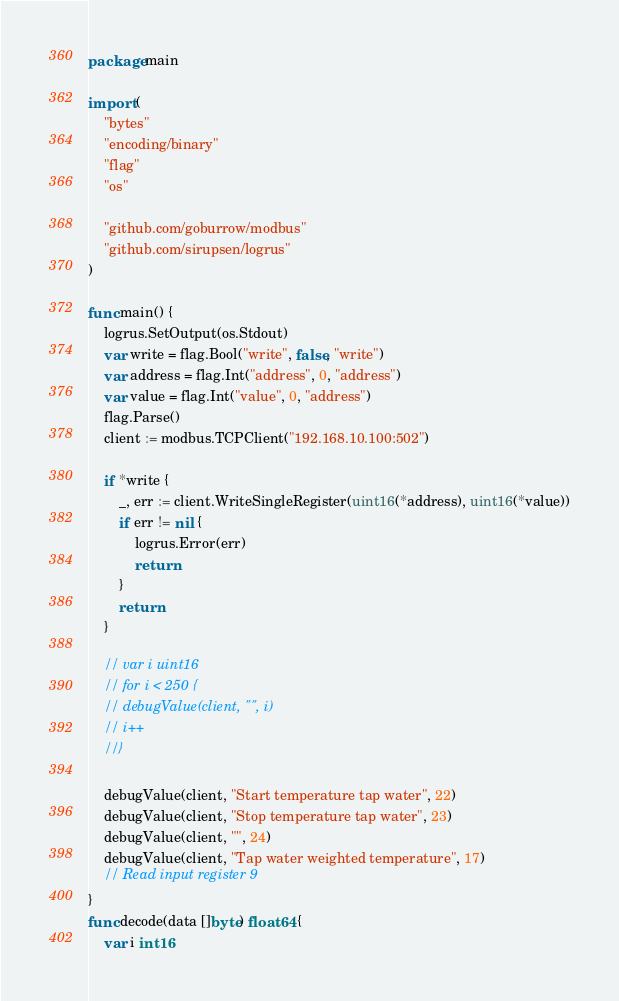Convert code to text. <code><loc_0><loc_0><loc_500><loc_500><_Go_>package main

import (
	"bytes"
	"encoding/binary"
	"flag"
	"os"

	"github.com/goburrow/modbus"
	"github.com/sirupsen/logrus"
)

func main() {
	logrus.SetOutput(os.Stdout)
	var write = flag.Bool("write", false, "write")
	var address = flag.Int("address", 0, "address")
	var value = flag.Int("value", 0, "address")
	flag.Parse()
	client := modbus.TCPClient("192.168.10.100:502")

	if *write {
		_, err := client.WriteSingleRegister(uint16(*address), uint16(*value))
		if err != nil {
			logrus.Error(err)
			return
		}
		return
	}

	// var i uint16
	// for i < 250 {
	// debugValue(client, "", i)
	// i++
	//}

	debugValue(client, "Start temperature tap water", 22)
	debugValue(client, "Stop temperature tap water", 23)
	debugValue(client, "", 24)
	debugValue(client, "Tap water weighted temperature", 17)
	// Read input register 9
}
func decode(data []byte) float64 {
	var i int16</code> 